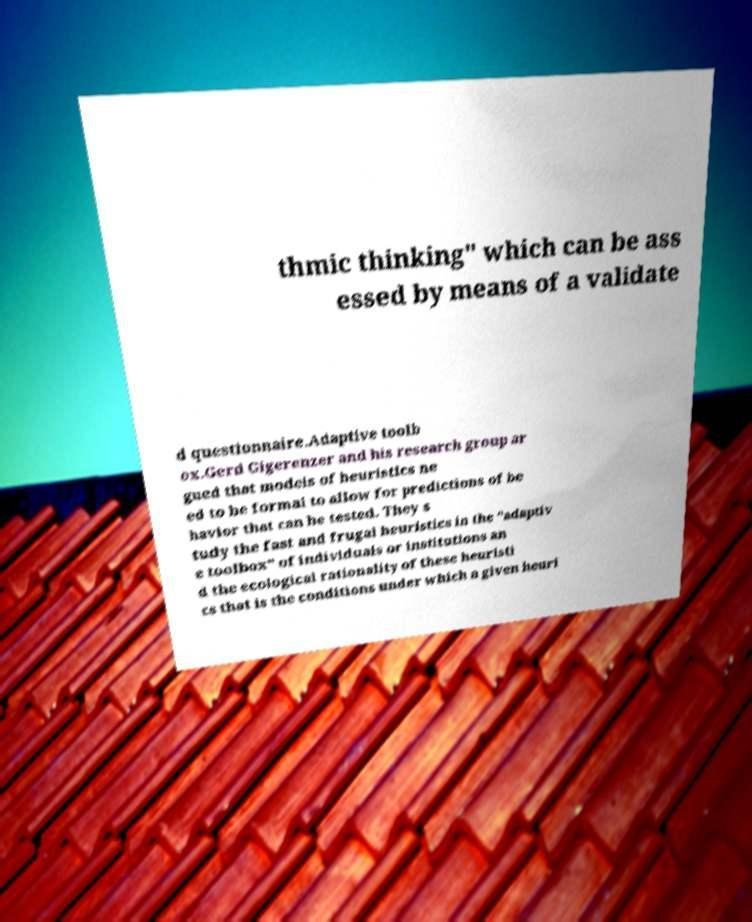Could you assist in decoding the text presented in this image and type it out clearly? thmic thinking" which can be ass essed by means of a validate d questionnaire.Adaptive toolb ox.Gerd Gigerenzer and his research group ar gued that models of heuristics ne ed to be formal to allow for predictions of be havior that can be tested. They s tudy the fast and frugal heuristics in the "adaptiv e toolbox" of individuals or institutions an d the ecological rationality of these heuristi cs that is the conditions under which a given heuri 